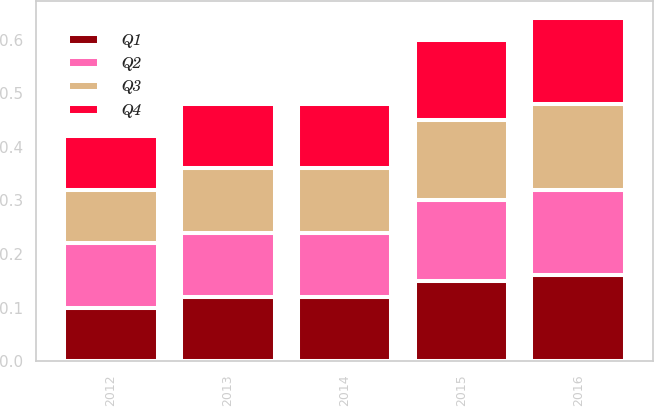<chart> <loc_0><loc_0><loc_500><loc_500><stacked_bar_chart><ecel><fcel>2016<fcel>2015<fcel>2014<fcel>2013<fcel>2012<nl><fcel>Q4<fcel>0.16<fcel>0.15<fcel>0.12<fcel>0.12<fcel>0.1<nl><fcel>Q1<fcel>0.16<fcel>0.15<fcel>0.12<fcel>0.12<fcel>0.1<nl><fcel>Q3<fcel>0.16<fcel>0.15<fcel>0.12<fcel>0.12<fcel>0.1<nl><fcel>Q2<fcel>0.16<fcel>0.15<fcel>0.12<fcel>0.12<fcel>0.12<nl></chart> 